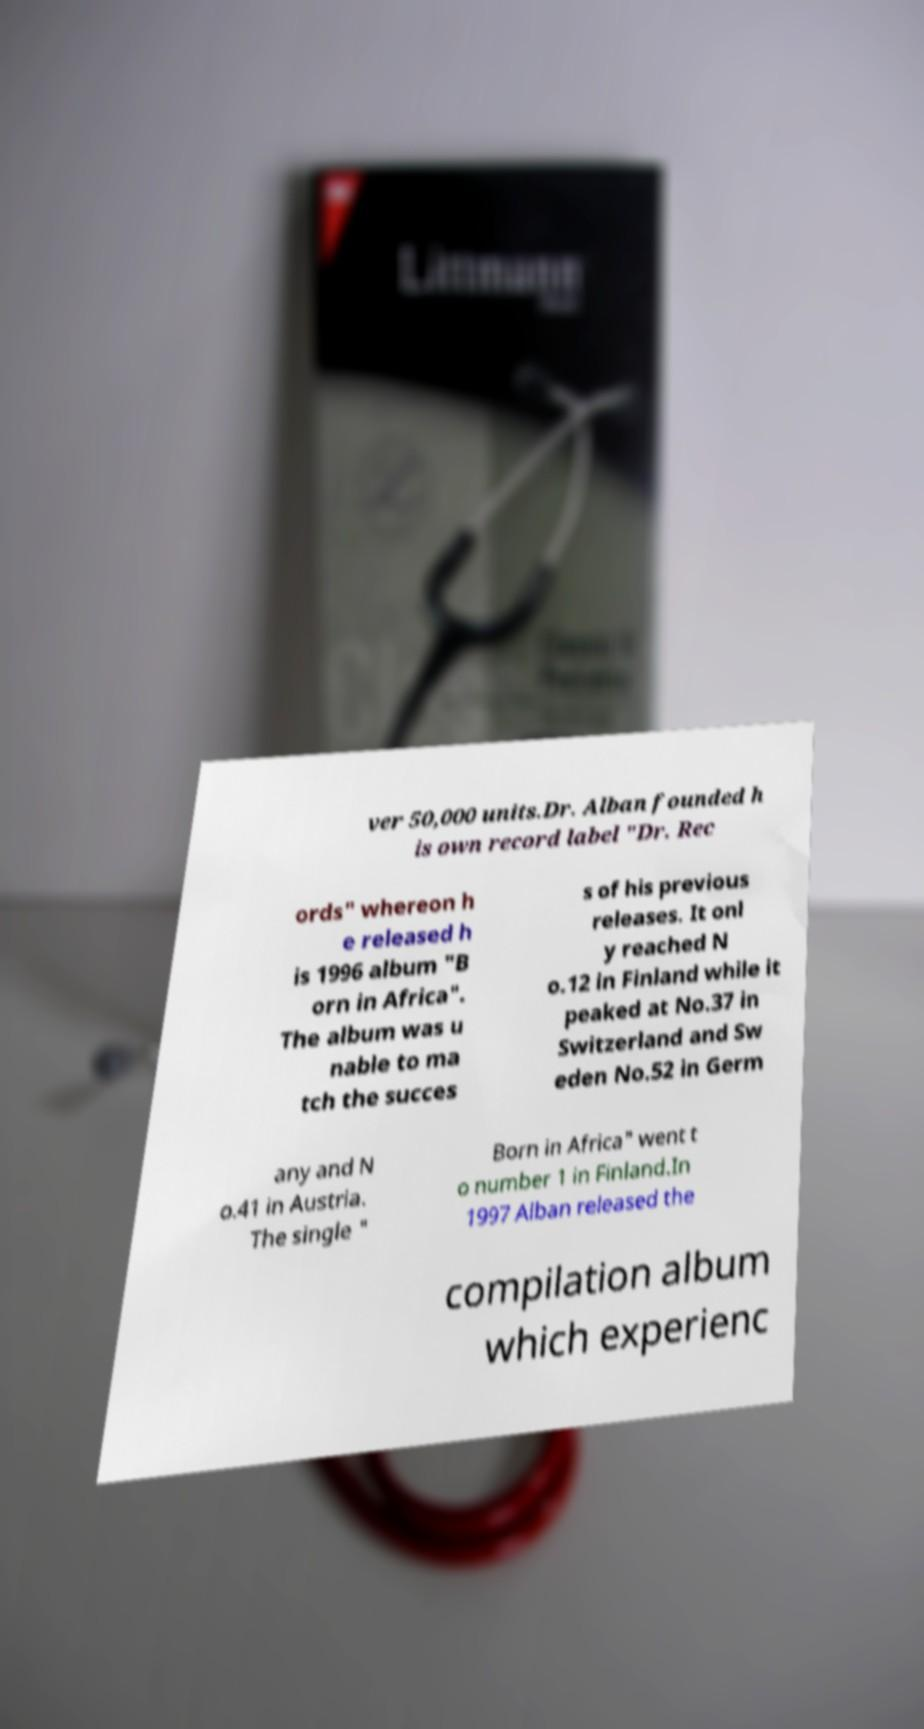I need the written content from this picture converted into text. Can you do that? ver 50,000 units.Dr. Alban founded h is own record label "Dr. Rec ords" whereon h e released h is 1996 album "B orn in Africa". The album was u nable to ma tch the succes s of his previous releases. It onl y reached N o.12 in Finland while it peaked at No.37 in Switzerland and Sw eden No.52 in Germ any and N o.41 in Austria. The single " Born in Africa" went t o number 1 in Finland.In 1997 Alban released the compilation album which experienc 